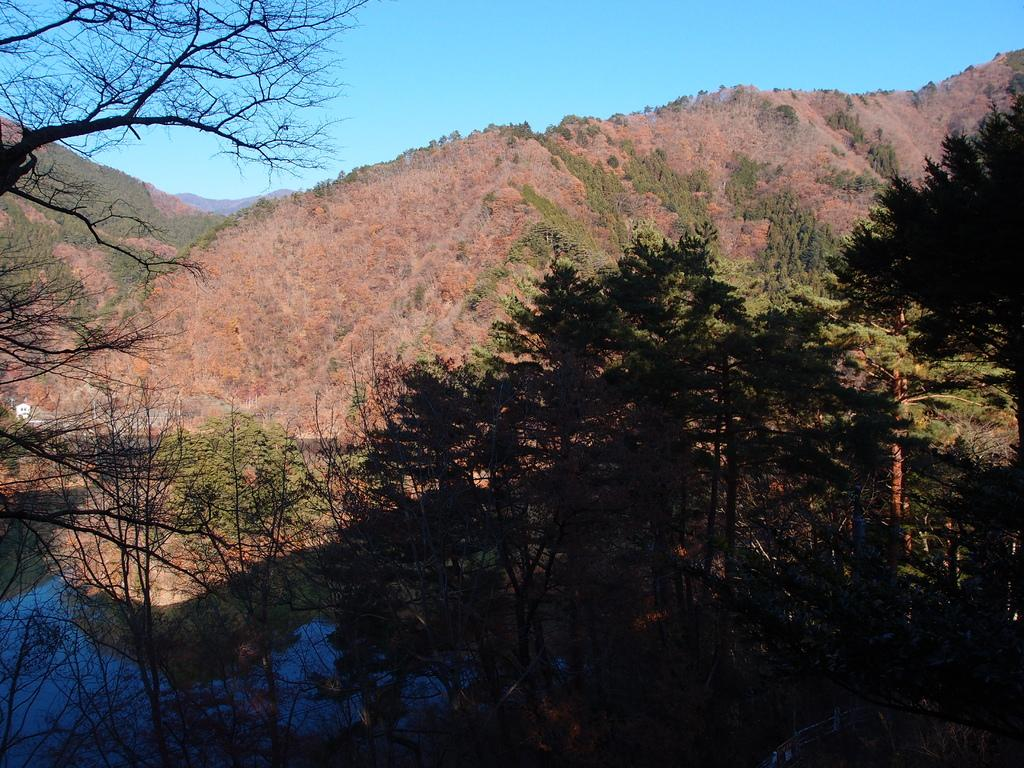What is the main geographical feature in the image? There is a mountain in the image. What is located in front of the mountain? There are trees in front of the mountain. Can you describe the condition of some of the trees? Some of the trees are dried. What can be seen on the left side of the image? There is a small pond on the left side of the image. What type of ear is visible on the stage in the image? There is no ear or stage present in the image; it features a mountain, trees, and a small pond. What kind of competition is taking place in the image? There is no competition present in the image; it features a mountain, trees, and a small pond. 